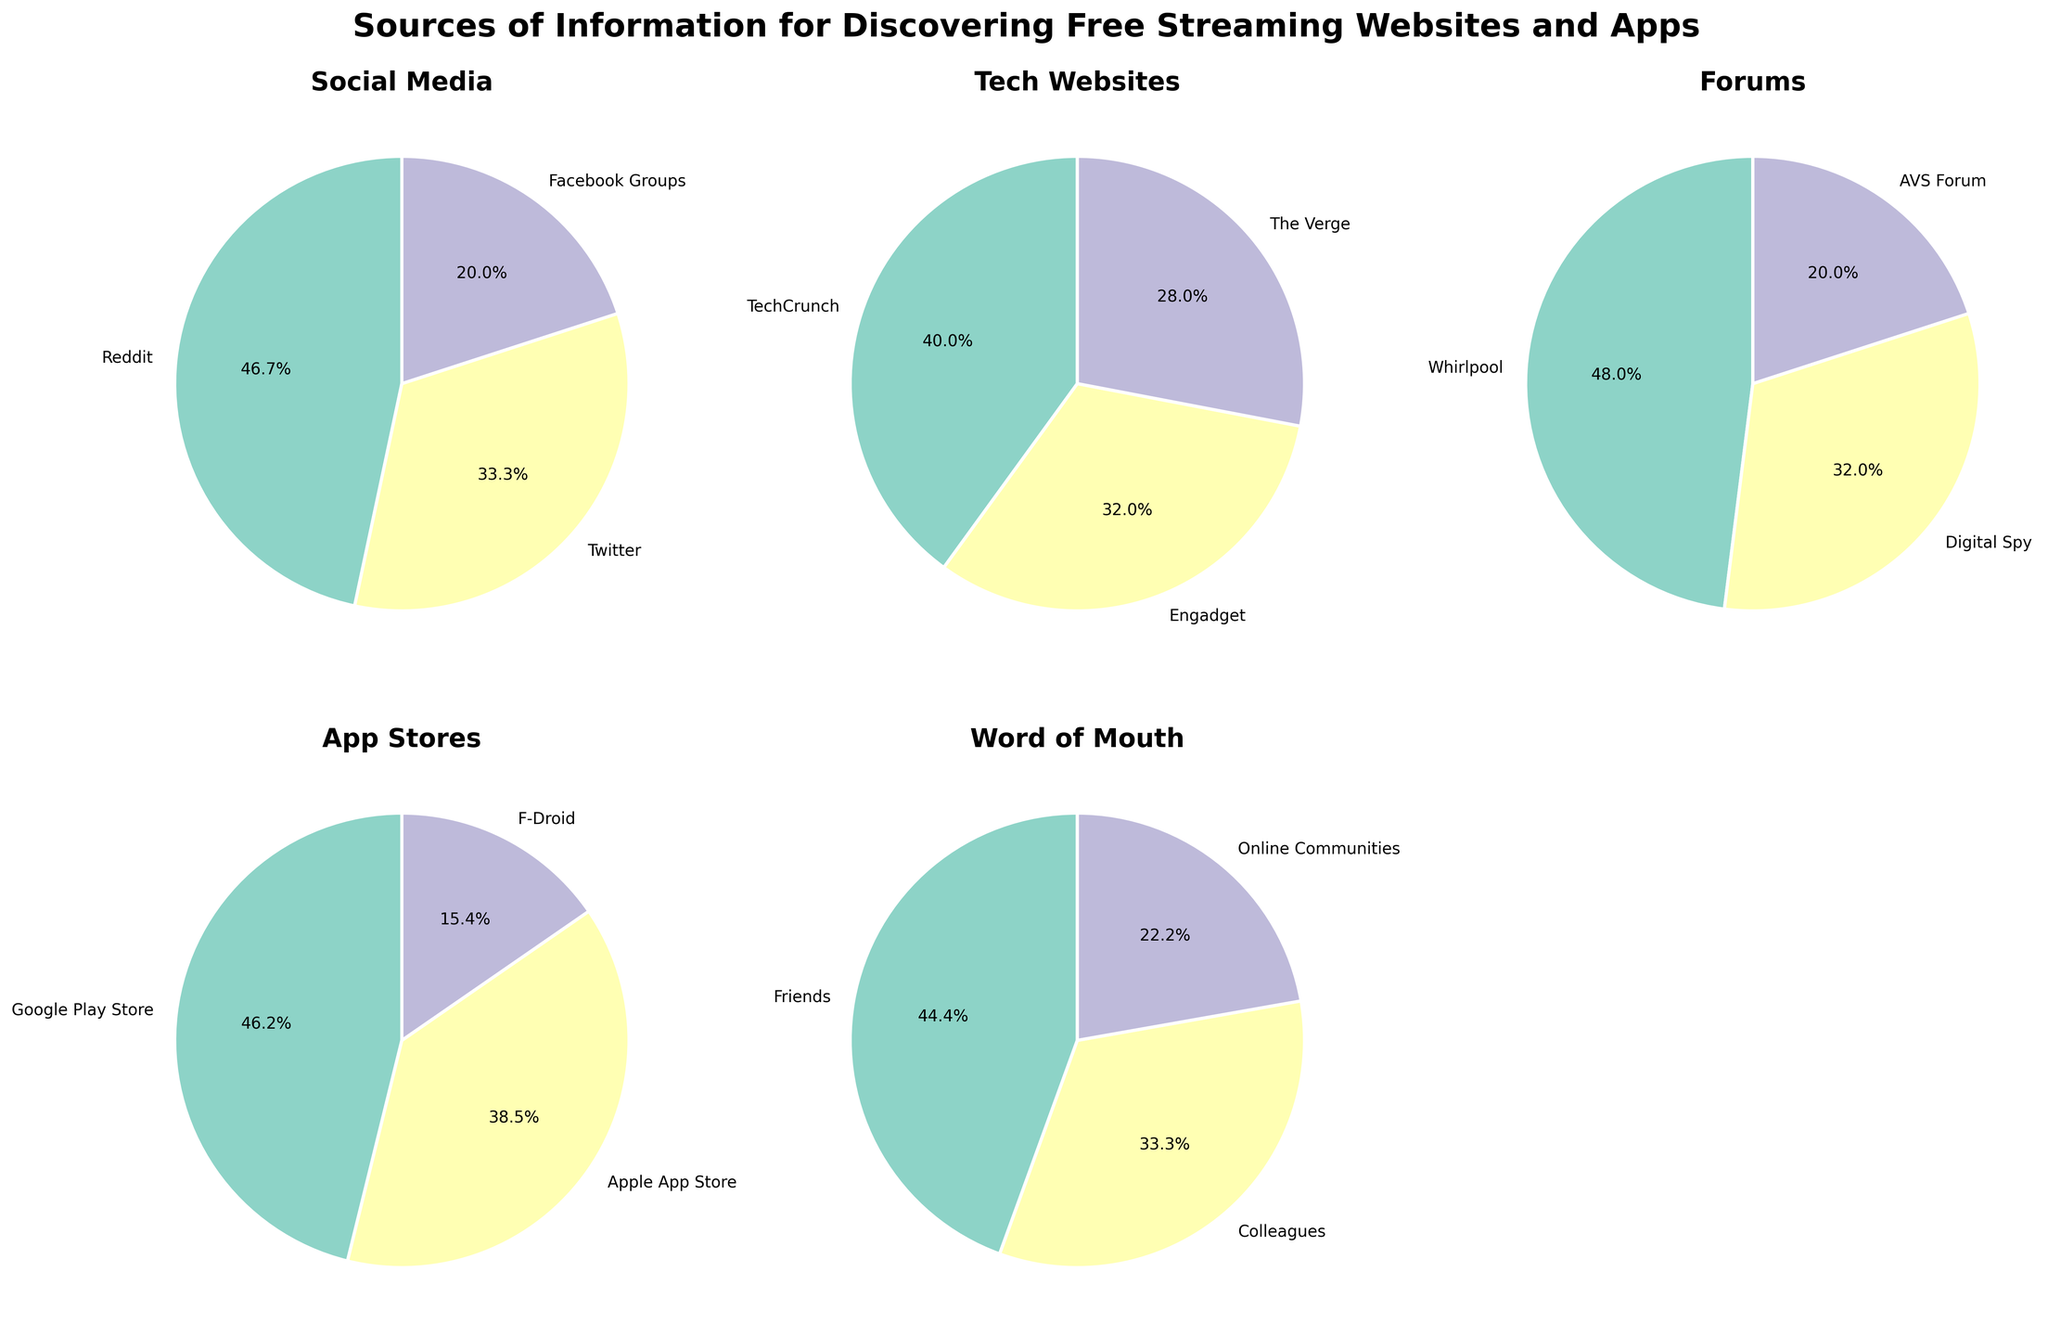How many categories are represented in the figure? To determine the number of categories, we count the distinct pie charts in the subplot. There are 5 categories in total: Social Media, Tech Websites, Forums, App Stores, and Word of Mouth.
Answer: 5 Which source has the highest percentage in Social Media? By examining the pie chart for Social Media, you can see that Reddit has the largest wedge, making up 35% of the sources.
Answer: Reddit What is the second largest source in App Stores? In the App Stores pie chart, Google Play Store has the highest percentage at 30%, and Apple App Store is next with 25%.
Answer: Apple App Store What is the combined percentage of Facebook Groups and The Verge? Look at the Social Media chart to find Facebook Groups (15%) and the Tech Websites chart for The Verge (7%). Add these percentages together: 15% + 7% = 22%.
Answer: 22% Which category has the lowest individual source percentage and what is it? Look through all the pie charts and identify the smallest wedge. The smallest wedge is AVS Forum in the Forums category with 5%.
Answer: Forums, AVS Forum How much higher is the percentage of Google Play Store compared to F-Droid in the App Stores category? Google Play Store has 30% and F-Droid has 10%. Subtract F-Droid’s percentage from Google Play Store’s: 30% - 10% = 20%.
Answer: 20% What is the total percentage represented by TechCrunch and Engadget combined? Locate TechCrunch (10%) and Engadget (8%) in the Tech Websites pie chart. Add these percentages together: 10% + 8% = 18%.
Answer: 18% Which source in Word of Mouth has 20%? Look at the Word of Mouth pie chart and identify the source corresponding to the 20% wedge. Friends constitute 20% of the sources.
Answer: Friends Is the percentage of Reddit in Social Media more than that of Digital Spy in Forums? Check the Social Media pie chart for Reddit (35%) and the Forums pie chart for Digital Spy (8%). Since 35% is greater than 8%, Reddit has a higher percentage.
Answer: Yes Compare the highest percentage source in Social Media to the highest percentage source in App Stores. Which one is larger? The highest percentage source in Social Media is Reddit with 35%. The highest in App Stores is Google Play Store with 30%. Since 35% is greater than 30%, Reddit is larger.
Answer: Reddit 